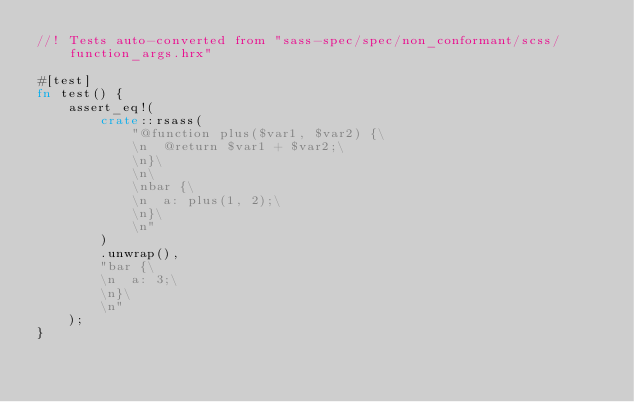<code> <loc_0><loc_0><loc_500><loc_500><_Rust_>//! Tests auto-converted from "sass-spec/spec/non_conformant/scss/function_args.hrx"

#[test]
fn test() {
    assert_eq!(
        crate::rsass(
            "@function plus($var1, $var2) {\
            \n  @return $var1 + $var2;\
            \n}\
            \n\
            \nbar {\
            \n  a: plus(1, 2);\
            \n}\
            \n"
        )
        .unwrap(),
        "bar {\
        \n  a: 3;\
        \n}\
        \n"
    );
}
</code> 